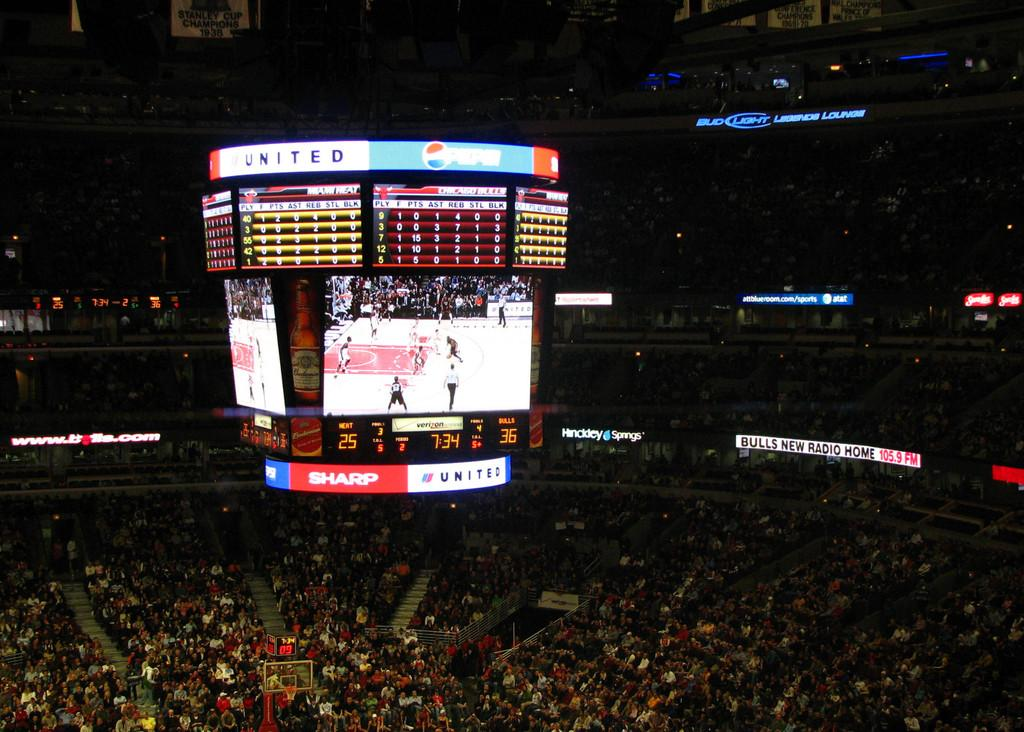Where is the image taken? The image is inside a stadium. What is happening in the stadium? There are many people in the stadium, and players are playing basketball in the middle of the image. How can you tell the score of the game? The score is visible on the top of the image. What type of quiver can be seen on the players' backs in the image? There are no quivers present in the image, as basketball players do not typically use quivers. How many times do the players turn around in the image? The image does not show the players turning around, so it is impossible to determine how many times they turn. 